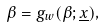Convert formula to latex. <formula><loc_0><loc_0><loc_500><loc_500>\beta = g _ { w } ( \beta ; \underline { x } ) ,</formula> 